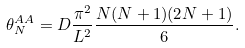<formula> <loc_0><loc_0><loc_500><loc_500>\theta _ { N } ^ { A A } = D \frac { \pi ^ { 2 } } { L ^ { 2 } } \frac { N ( N + 1 ) ( 2 N + 1 ) } { 6 } .</formula> 